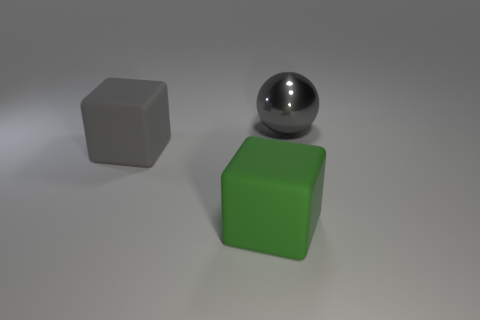Add 1 large gray metal spheres. How many objects exist? 4 Subtract all green blocks. How many blocks are left? 1 Subtract all blue balls. How many gray cubes are left? 1 Add 2 large gray things. How many large gray things exist? 4 Subtract 0 blue cubes. How many objects are left? 3 Subtract all blocks. How many objects are left? 1 Subtract all yellow spheres. Subtract all green blocks. How many spheres are left? 1 Subtract all large objects. Subtract all big blue shiny objects. How many objects are left? 0 Add 1 big gray balls. How many big gray balls are left? 2 